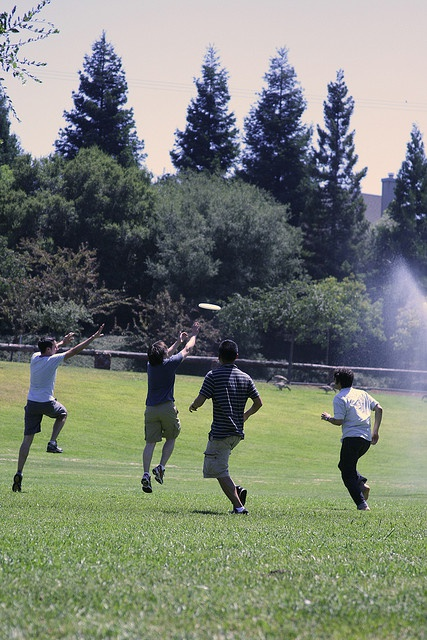Describe the objects in this image and their specific colors. I can see people in lightgray, black, and gray tones, people in lightgray, black, gray, and olive tones, people in lightgray, black, gray, and ivory tones, people in lightgray, black, and gray tones, and frisbee in lightgray, beige, darkgray, black, and gray tones in this image. 